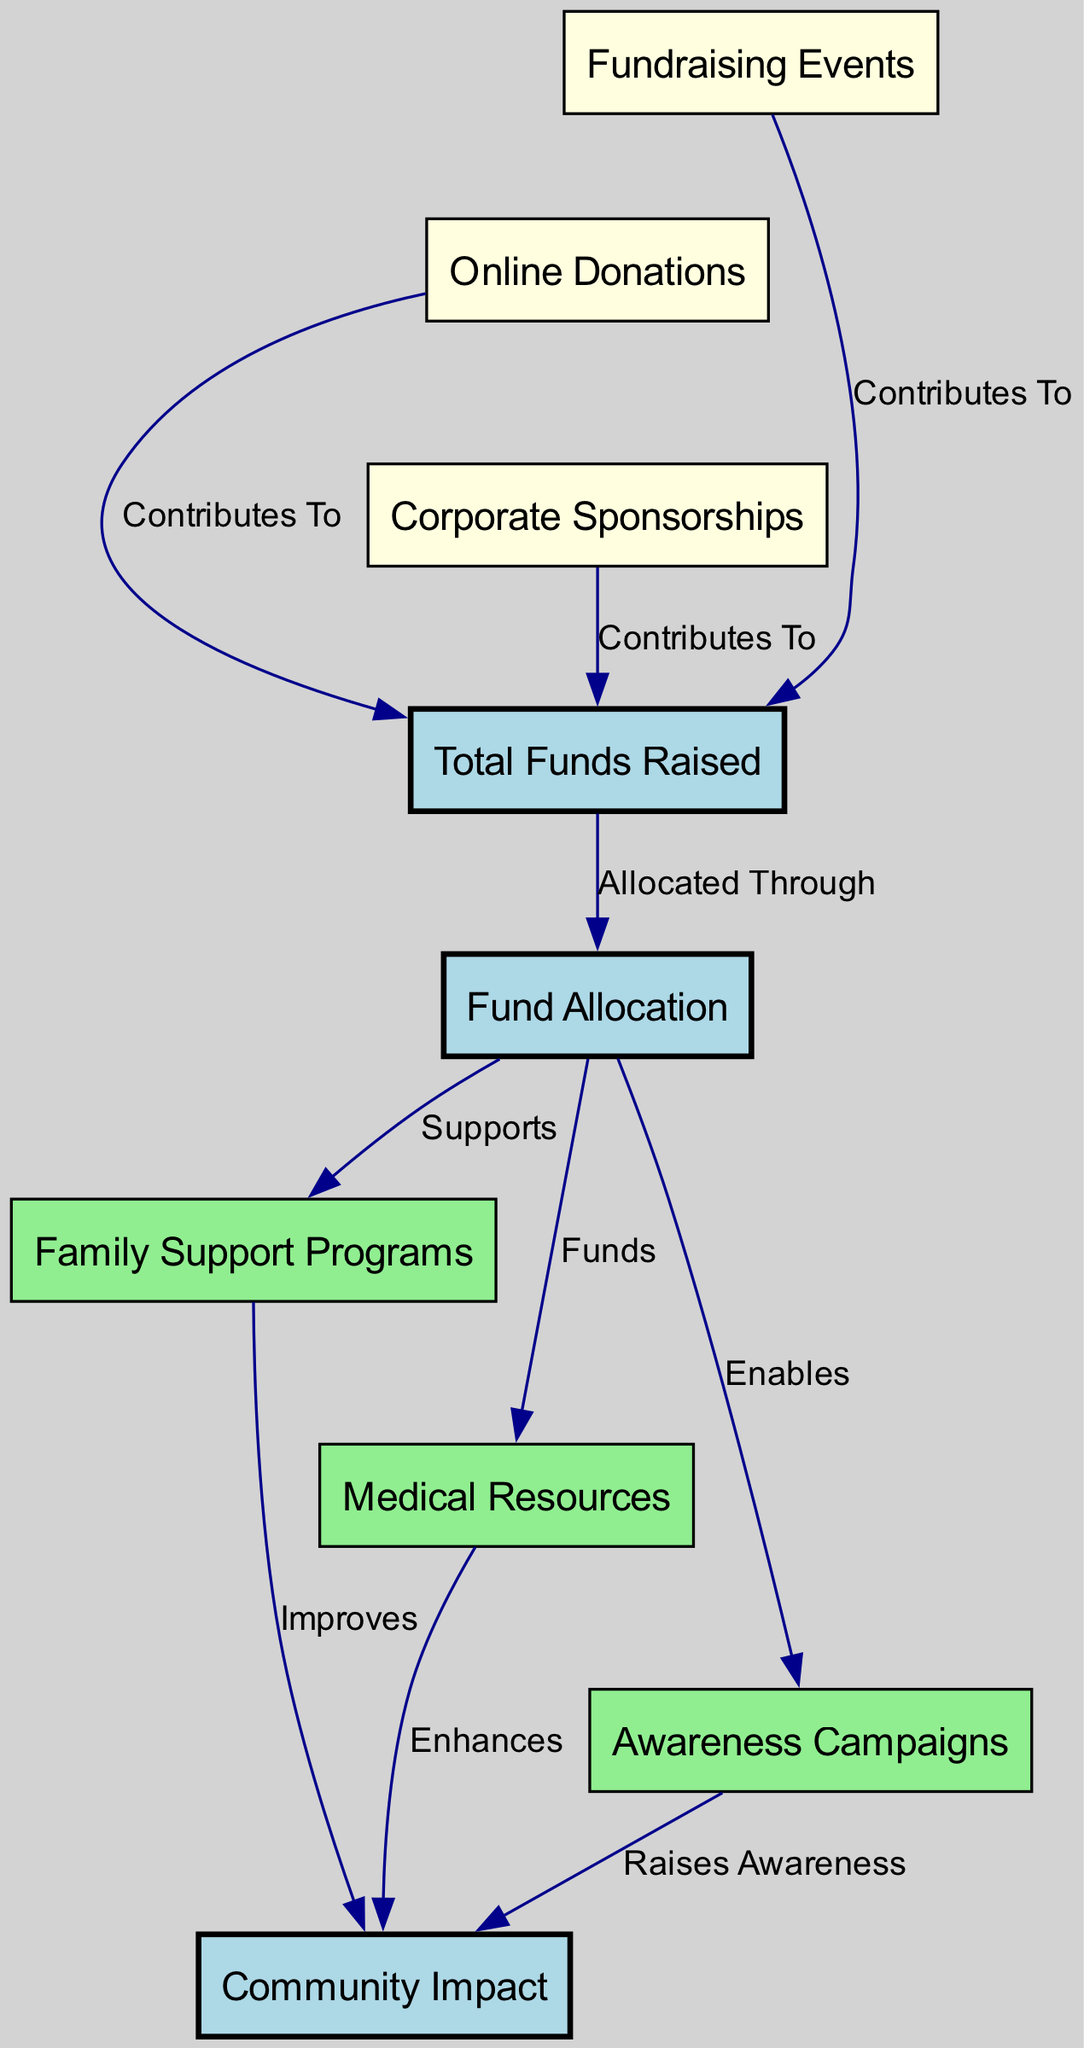What are the fundraising sources used? The diagram identifies three fundraising sources: "Fundraising Events," "Online Donations," and "Corporate Sponsorships." These sources directly contribute to the "Total Funds Raised."
Answer: Fundraising Events, Online Donations, Corporate Sponsorships How many total nodes are in the diagram? The diagram contains nine nodes in total, which include key components involved in fundraising and the impact on the community.
Answer: 9 What does "Total Funds Raised" allocate to? "Total Funds Raised" is allocated to three areas: "Family Support Programs," "Medical Resources," and "Awareness Campaigns," which are shown to receive the allocated funds.
Answer: Family Support Programs, Medical Resources, Awareness Campaigns Which node improves community impact? The "Family Support Programs," when funded, show a direct arrow labeled "Improves" pointing to the "Community Impact," indicating their role in enhancing community welfare.
Answer: Family Support Programs How does "Online Donations" affect "Total Funds Raised"? The "Online Donations" node is connected to the "Total Funds Raised" node with an edge labeled "Contributes To," indicating that online donations play a role in raising funds.
Answer: Contributes To What is the overall impact of "Awareness Campaigns"? The "Awareness Campaigns" node raises awareness as indicated by the arrow leading to "Community Impact," showing how these campaigns influence the community positively.
Answer: Raises Awareness Which component supports "Medical Resources"? The "Fund Allocation" node has a direct link labeled "Funds" connecting to the "Medical Resources" node, indicating that funds are specifically allocated to support medical resources.
Answer: Funds What enhances community impact? The "Medical Resources" node is linked to "Community Impact" with an edge labeled "Enhances," suggesting that providing medical resources has a positive effect on the community.
Answer: Enhances What type of fundraising lead to the total funds? The three types of fundraising activities, which include "Fundraising Events," "Online Donations," and "Corporate Sponsorships," all lead to the total funds raised as represented in the diagram.
Answer: Fundraising Events, Online Donations, Corporate Sponsorships 